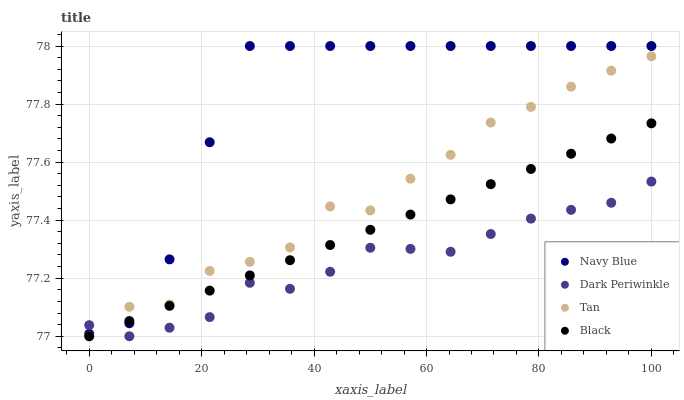Does Dark Periwinkle have the minimum area under the curve?
Answer yes or no. Yes. Does Navy Blue have the maximum area under the curve?
Answer yes or no. Yes. Does Tan have the minimum area under the curve?
Answer yes or no. No. Does Tan have the maximum area under the curve?
Answer yes or no. No. Is Black the smoothest?
Answer yes or no. Yes. Is Tan the roughest?
Answer yes or no. Yes. Is Tan the smoothest?
Answer yes or no. No. Is Black the roughest?
Answer yes or no. No. Does Tan have the lowest value?
Answer yes or no. Yes. Does Navy Blue have the highest value?
Answer yes or no. Yes. Does Tan have the highest value?
Answer yes or no. No. Does Navy Blue intersect Tan?
Answer yes or no. Yes. Is Navy Blue less than Tan?
Answer yes or no. No. Is Navy Blue greater than Tan?
Answer yes or no. No. 